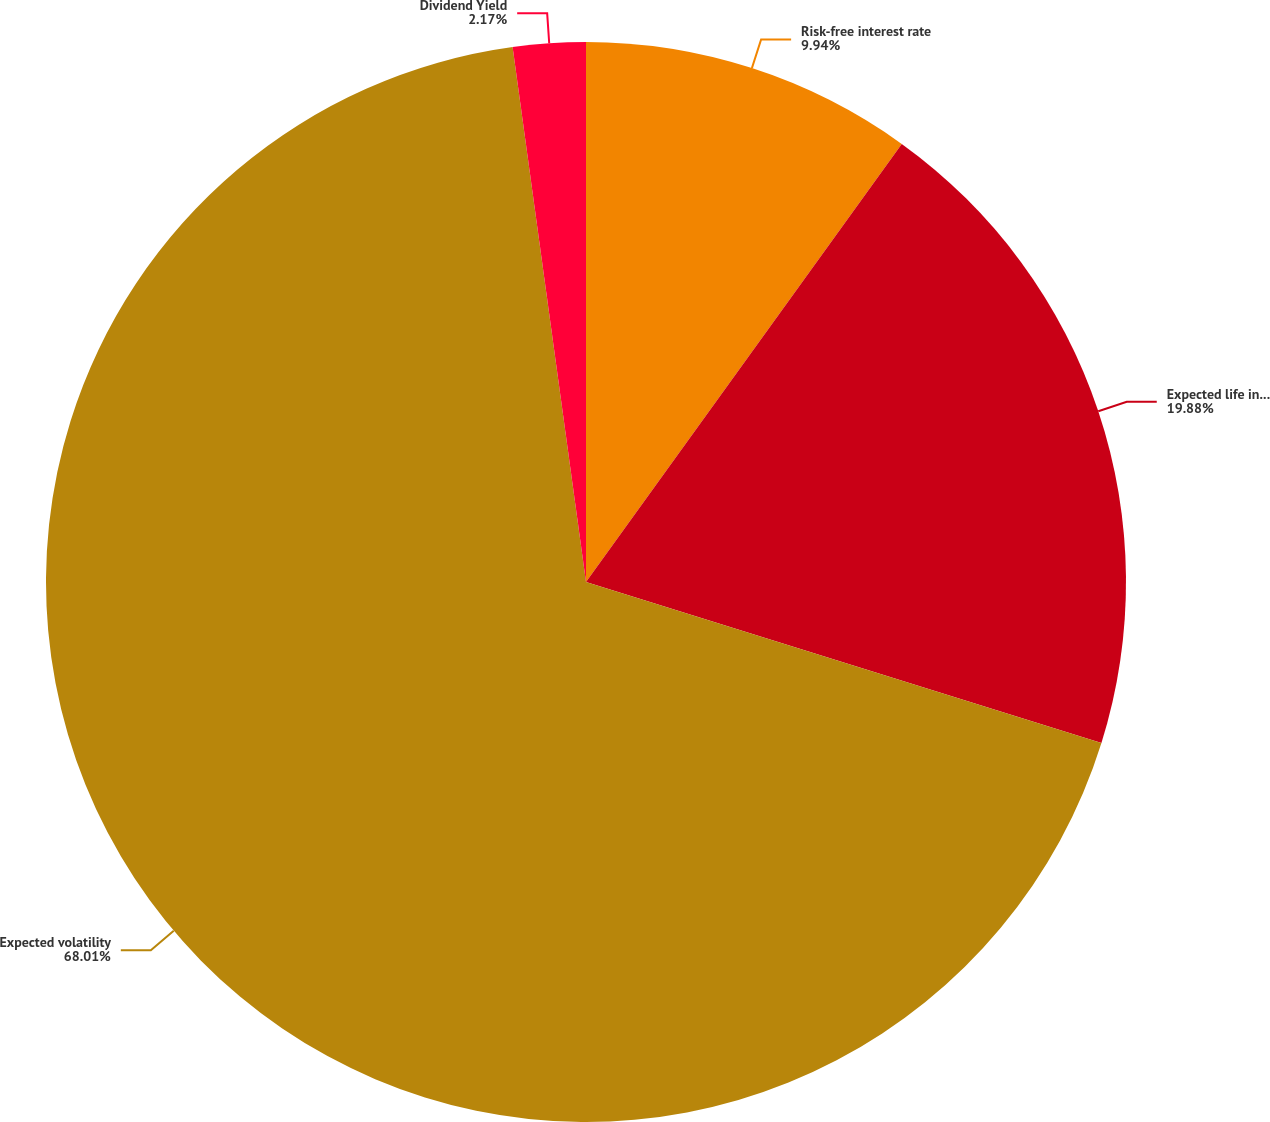Convert chart to OTSL. <chart><loc_0><loc_0><loc_500><loc_500><pie_chart><fcel>Risk-free interest rate<fcel>Expected life in Years<fcel>Expected volatility<fcel>Dividend Yield<nl><fcel>9.94%<fcel>19.88%<fcel>68.01%<fcel>2.17%<nl></chart> 